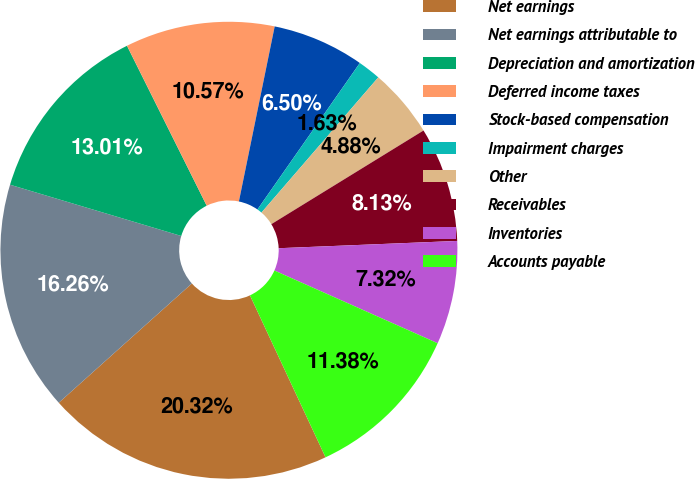<chart> <loc_0><loc_0><loc_500><loc_500><pie_chart><fcel>Net earnings<fcel>Net earnings attributable to<fcel>Depreciation and amortization<fcel>Deferred income taxes<fcel>Stock-based compensation<fcel>Impairment charges<fcel>Other<fcel>Receivables<fcel>Inventories<fcel>Accounts payable<nl><fcel>20.32%<fcel>16.26%<fcel>13.01%<fcel>10.57%<fcel>6.5%<fcel>1.63%<fcel>4.88%<fcel>8.13%<fcel>7.32%<fcel>11.38%<nl></chart> 